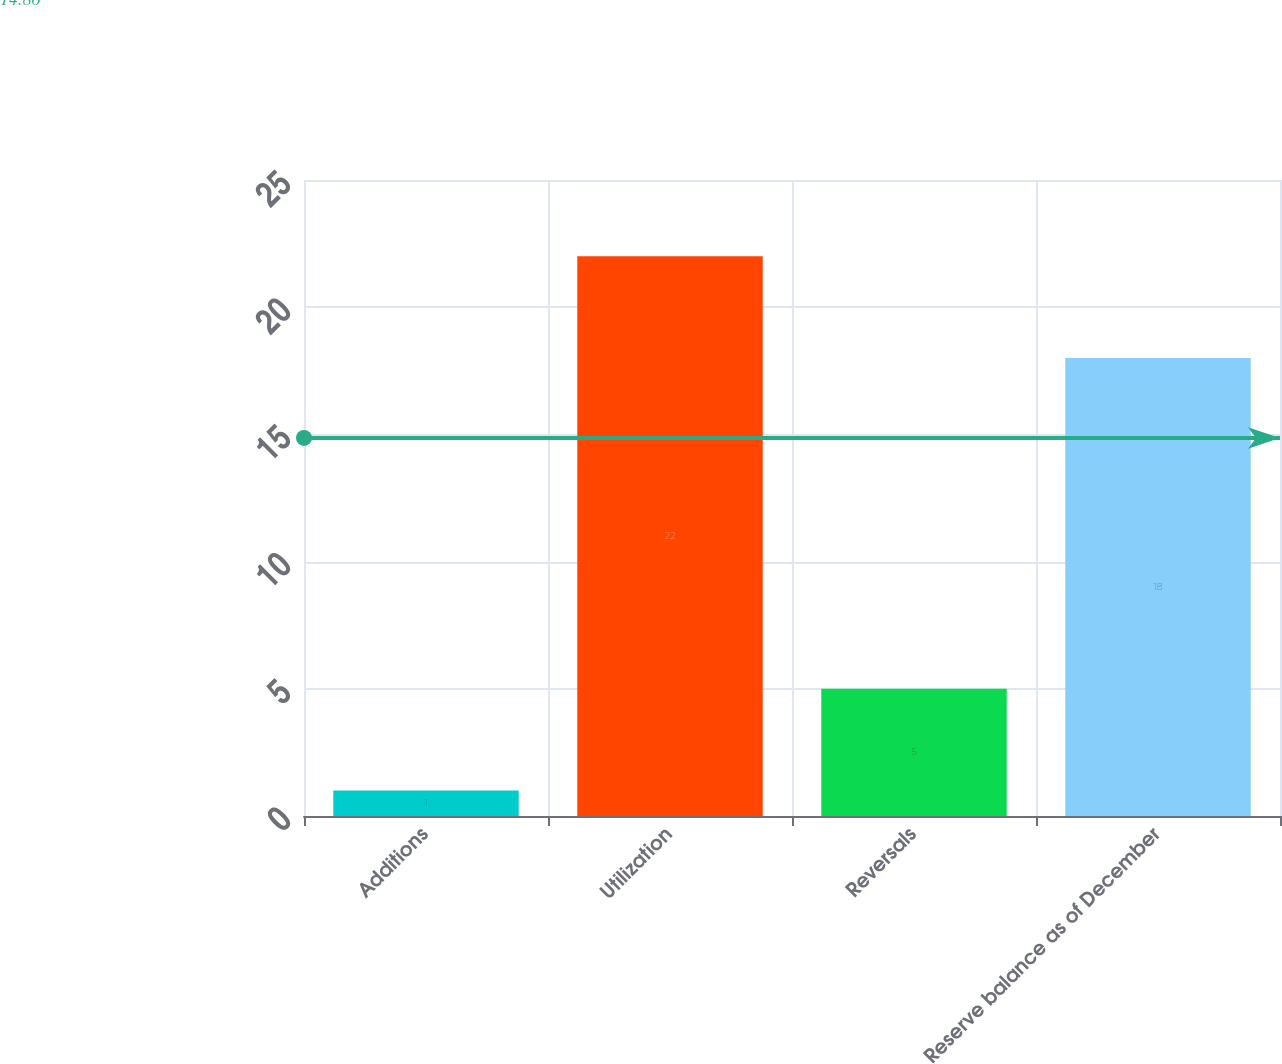Convert chart to OTSL. <chart><loc_0><loc_0><loc_500><loc_500><bar_chart><fcel>Additions<fcel>Utilization<fcel>Reversals<fcel>Reserve balance as of December<nl><fcel>1<fcel>22<fcel>5<fcel>18<nl></chart> 